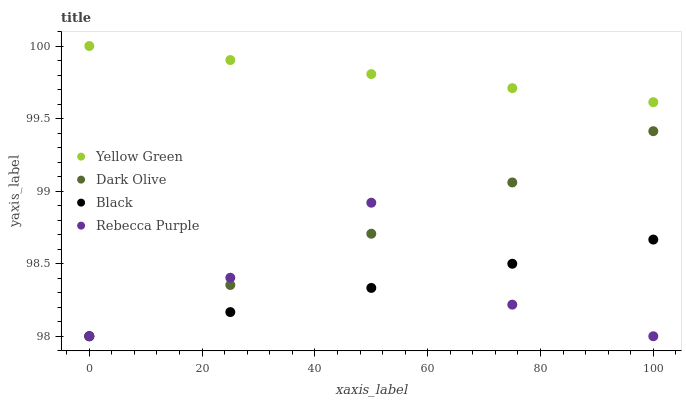Does Black have the minimum area under the curve?
Answer yes or no. Yes. Does Yellow Green have the maximum area under the curve?
Answer yes or no. Yes. Does Yellow Green have the minimum area under the curve?
Answer yes or no. No. Does Black have the maximum area under the curve?
Answer yes or no. No. Is Yellow Green the smoothest?
Answer yes or no. Yes. Is Rebecca Purple the roughest?
Answer yes or no. Yes. Is Black the smoothest?
Answer yes or no. No. Is Black the roughest?
Answer yes or no. No. Does Dark Olive have the lowest value?
Answer yes or no. Yes. Does Yellow Green have the lowest value?
Answer yes or no. No. Does Yellow Green have the highest value?
Answer yes or no. Yes. Does Black have the highest value?
Answer yes or no. No. Is Dark Olive less than Yellow Green?
Answer yes or no. Yes. Is Yellow Green greater than Dark Olive?
Answer yes or no. Yes. Does Black intersect Dark Olive?
Answer yes or no. Yes. Is Black less than Dark Olive?
Answer yes or no. No. Is Black greater than Dark Olive?
Answer yes or no. No. Does Dark Olive intersect Yellow Green?
Answer yes or no. No. 